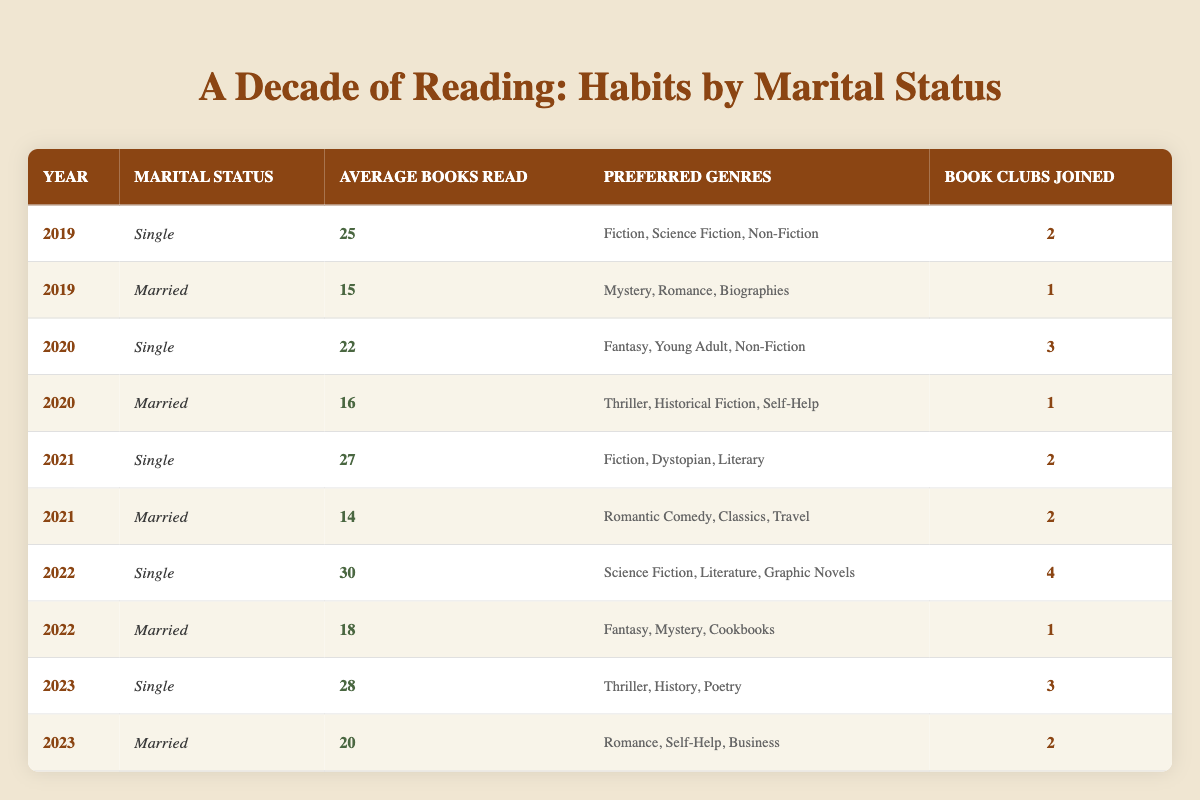What is the average number of books read by married individuals in 2019? The table indicates that in 2019, married people read an average of 15 books. There is only one entry for married individuals in that year, making the average value the same as the number of books read.
Answer: 15 In which year did single individuals read the most books on average? By examining the average books read by single individuals across the years: 2019 (25), 2020 (22), 2021 (27), 2022 (30), and 2023 (28). The highest number is 30 in 2022.
Answer: 2022 Did married individuals join more book clubs than single individuals in 2021? In 2021, married people joined 2 book clubs while single individuals joined 2 as well, indicating they joined the same number of clubs.
Answer: No What is the total average number of books read by single individuals from 2019 to 2023? First, sum the average books read by single individuals for all years: 25 (2019) + 22 (2020) + 27 (2021) + 30 (2022) + 28 (2023) = 132. Then divide by the number of years (5): 132 / 5 = 26.4.
Answer: 26.4 Which preferred genre was common among married individuals in 2019 and 2020? Looking at the preferred genres of married individuals in 2019 and 2020, we see in 2019 they preferred "Mystery, Romance, Biographies" and in 2020 it was "Thriller, Historical Fiction, Self-Help." There are no overlapping genres between these two years.
Answer: None How many book clubs did single individuals join in total from 2019 to 2022? Add the number of book clubs single individuals joined each year from 2019 to 2022: 2 (2019) + 3 (2020) + 2 (2021) + 4 (2022) = 11.
Answer: 11 True or False: Married individuals read more than single individuals in the year 2020. In 2020, married individuals read an average of 16 books while single individuals read an average of 22 books. Thus, the statement is false.
Answer: False What is the difference in average books read between single and married individuals in 2023? For 2023, single individuals read 28 books and married individuals read 20 books. To find the difference, subtract the married average from the single average: 28 - 20 = 8.
Answer: 8 